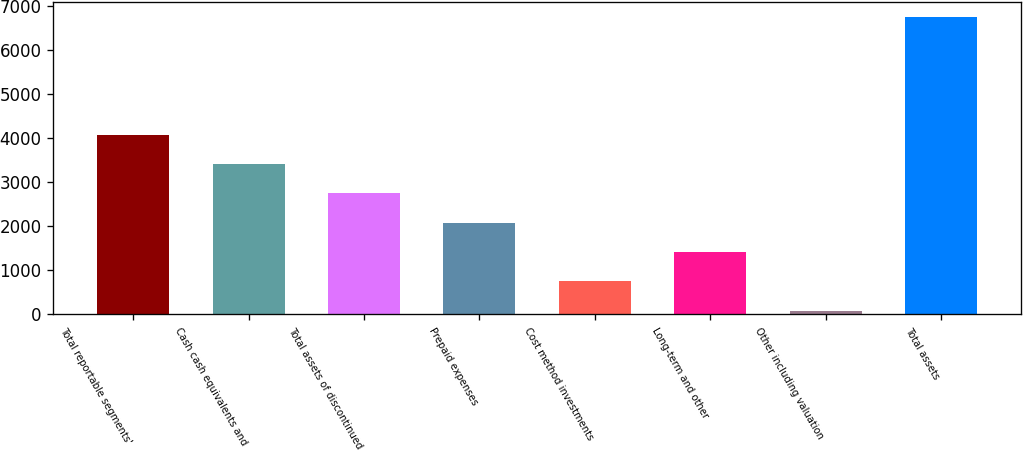Convert chart to OTSL. <chart><loc_0><loc_0><loc_500><loc_500><bar_chart><fcel>Total reportable segments'<fcel>Cash cash equivalents and<fcel>Total assets of discontinued<fcel>Prepaid expenses<fcel>Cost method investments<fcel>Long-term and other<fcel>Other including valuation<fcel>Total assets<nl><fcel>4081.8<fcel>3414.5<fcel>2747.2<fcel>2079.9<fcel>745.3<fcel>1412.6<fcel>78<fcel>6751<nl></chart> 